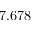<formula> <loc_0><loc_0><loc_500><loc_500>7 . 6 7 8</formula> 